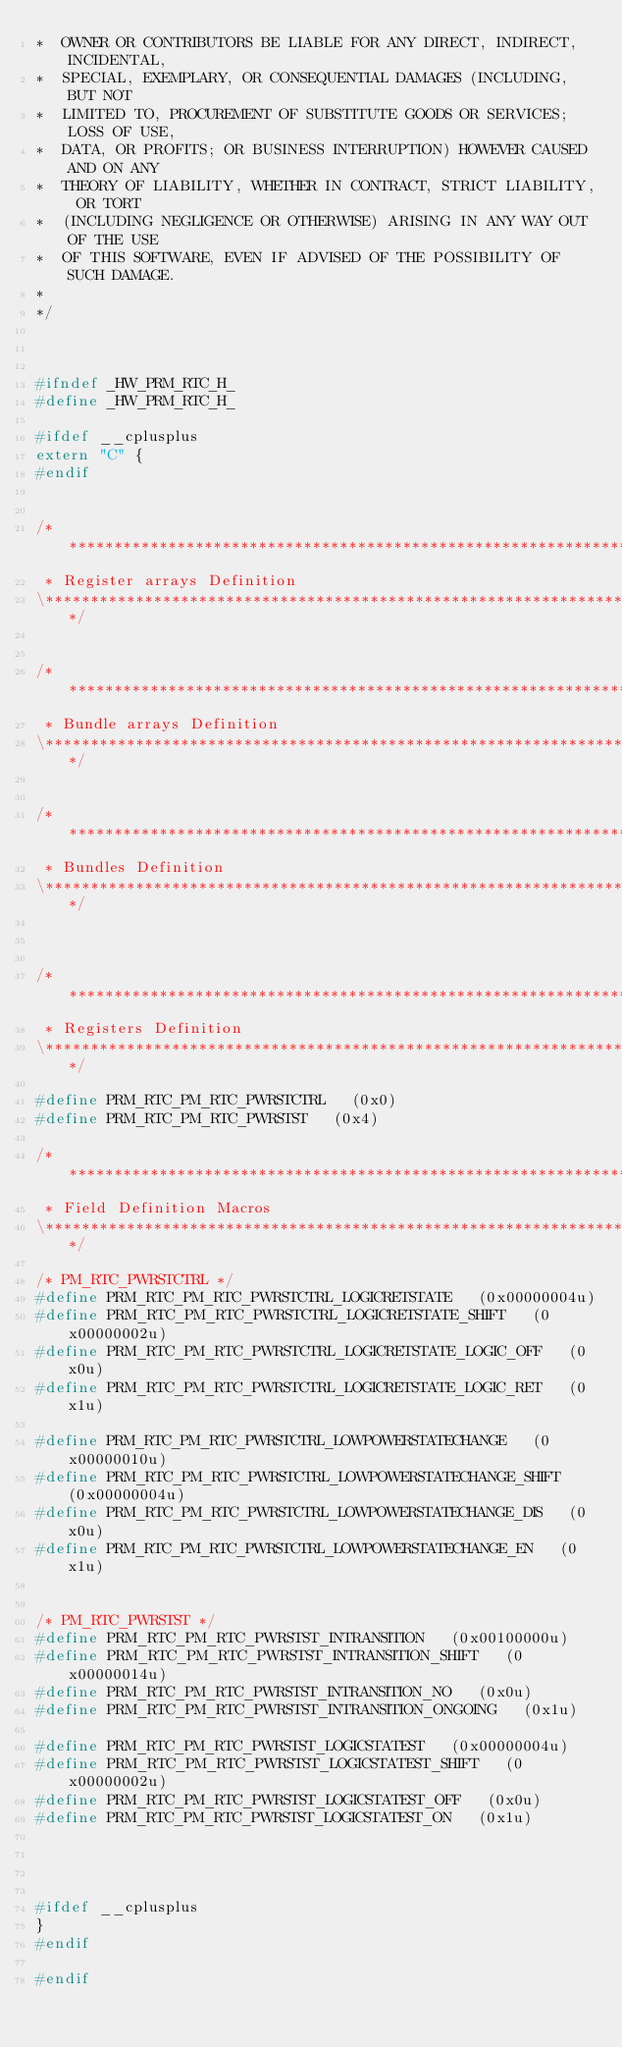<code> <loc_0><loc_0><loc_500><loc_500><_C_>*  OWNER OR CONTRIBUTORS BE LIABLE FOR ANY DIRECT, INDIRECT, INCIDENTAL,
*  SPECIAL, EXEMPLARY, OR CONSEQUENTIAL DAMAGES (INCLUDING, BUT NOT
*  LIMITED TO, PROCUREMENT OF SUBSTITUTE GOODS OR SERVICES; LOSS OF USE,
*  DATA, OR PROFITS; OR BUSINESS INTERRUPTION) HOWEVER CAUSED AND ON ANY
*  THEORY OF LIABILITY, WHETHER IN CONTRACT, STRICT LIABILITY, OR TORT
*  (INCLUDING NEGLIGENCE OR OTHERWISE) ARISING IN ANY WAY OUT OF THE USE
*  OF THIS SOFTWARE, EVEN IF ADVISED OF THE POSSIBILITY OF SUCH DAMAGE.
*
*/



#ifndef _HW_PRM_RTC_H_
#define _HW_PRM_RTC_H_

#ifdef __cplusplus
extern "C" {
#endif


/***********************************************************************\
 * Register arrays Definition
\***********************************************************************/


/***********************************************************************\
 * Bundle arrays Definition
\***********************************************************************/


/***********************************************************************\
 * Bundles Definition
\***********************************************************************/



/*************************************************************************\
 * Registers Definition
\*************************************************************************/

#define PRM_RTC_PM_RTC_PWRSTCTRL   (0x0)
#define PRM_RTC_PM_RTC_PWRSTST   (0x4)

/**************************************************************************\
 * Field Definition Macros
\**************************************************************************/

/* PM_RTC_PWRSTCTRL */
#define PRM_RTC_PM_RTC_PWRSTCTRL_LOGICRETSTATE   (0x00000004u)
#define PRM_RTC_PM_RTC_PWRSTCTRL_LOGICRETSTATE_SHIFT   (0x00000002u)
#define PRM_RTC_PM_RTC_PWRSTCTRL_LOGICRETSTATE_LOGIC_OFF   (0x0u)
#define PRM_RTC_PM_RTC_PWRSTCTRL_LOGICRETSTATE_LOGIC_RET   (0x1u)

#define PRM_RTC_PM_RTC_PWRSTCTRL_LOWPOWERSTATECHANGE   (0x00000010u)
#define PRM_RTC_PM_RTC_PWRSTCTRL_LOWPOWERSTATECHANGE_SHIFT   (0x00000004u)
#define PRM_RTC_PM_RTC_PWRSTCTRL_LOWPOWERSTATECHANGE_DIS   (0x0u)
#define PRM_RTC_PM_RTC_PWRSTCTRL_LOWPOWERSTATECHANGE_EN   (0x1u)


/* PM_RTC_PWRSTST */
#define PRM_RTC_PM_RTC_PWRSTST_INTRANSITION   (0x00100000u)
#define PRM_RTC_PM_RTC_PWRSTST_INTRANSITION_SHIFT   (0x00000014u)
#define PRM_RTC_PM_RTC_PWRSTST_INTRANSITION_NO   (0x0u)
#define PRM_RTC_PM_RTC_PWRSTST_INTRANSITION_ONGOING   (0x1u)

#define PRM_RTC_PM_RTC_PWRSTST_LOGICSTATEST   (0x00000004u)
#define PRM_RTC_PM_RTC_PWRSTST_LOGICSTATEST_SHIFT   (0x00000002u)
#define PRM_RTC_PM_RTC_PWRSTST_LOGICSTATEST_OFF   (0x0u)
#define PRM_RTC_PM_RTC_PWRSTST_LOGICSTATEST_ON   (0x1u)




#ifdef __cplusplus
}
#endif

#endif
</code> 